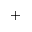<formula> <loc_0><loc_0><loc_500><loc_500>^ { + }</formula> 